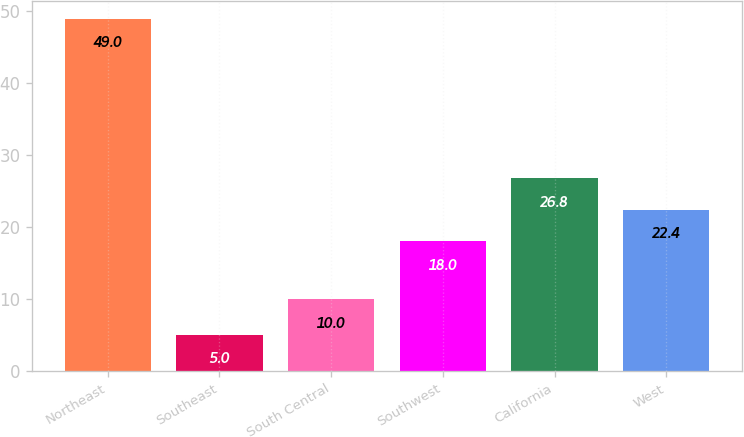Convert chart. <chart><loc_0><loc_0><loc_500><loc_500><bar_chart><fcel>Northeast<fcel>Southeast<fcel>South Central<fcel>Southwest<fcel>California<fcel>West<nl><fcel>49<fcel>5<fcel>10<fcel>18<fcel>26.8<fcel>22.4<nl></chart> 